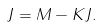Convert formula to latex. <formula><loc_0><loc_0><loc_500><loc_500>J = M - K J .</formula> 